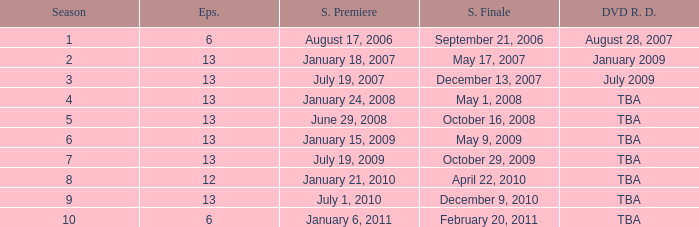On what date was the DVD released for the season with fewer than 13 episodes that aired before season 8? August 28, 2007. 